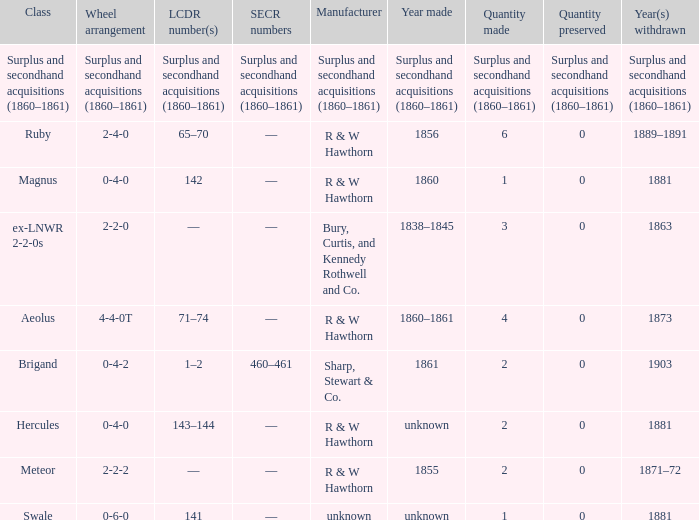What was the SECR number of the item made in 1861? 460–461. 